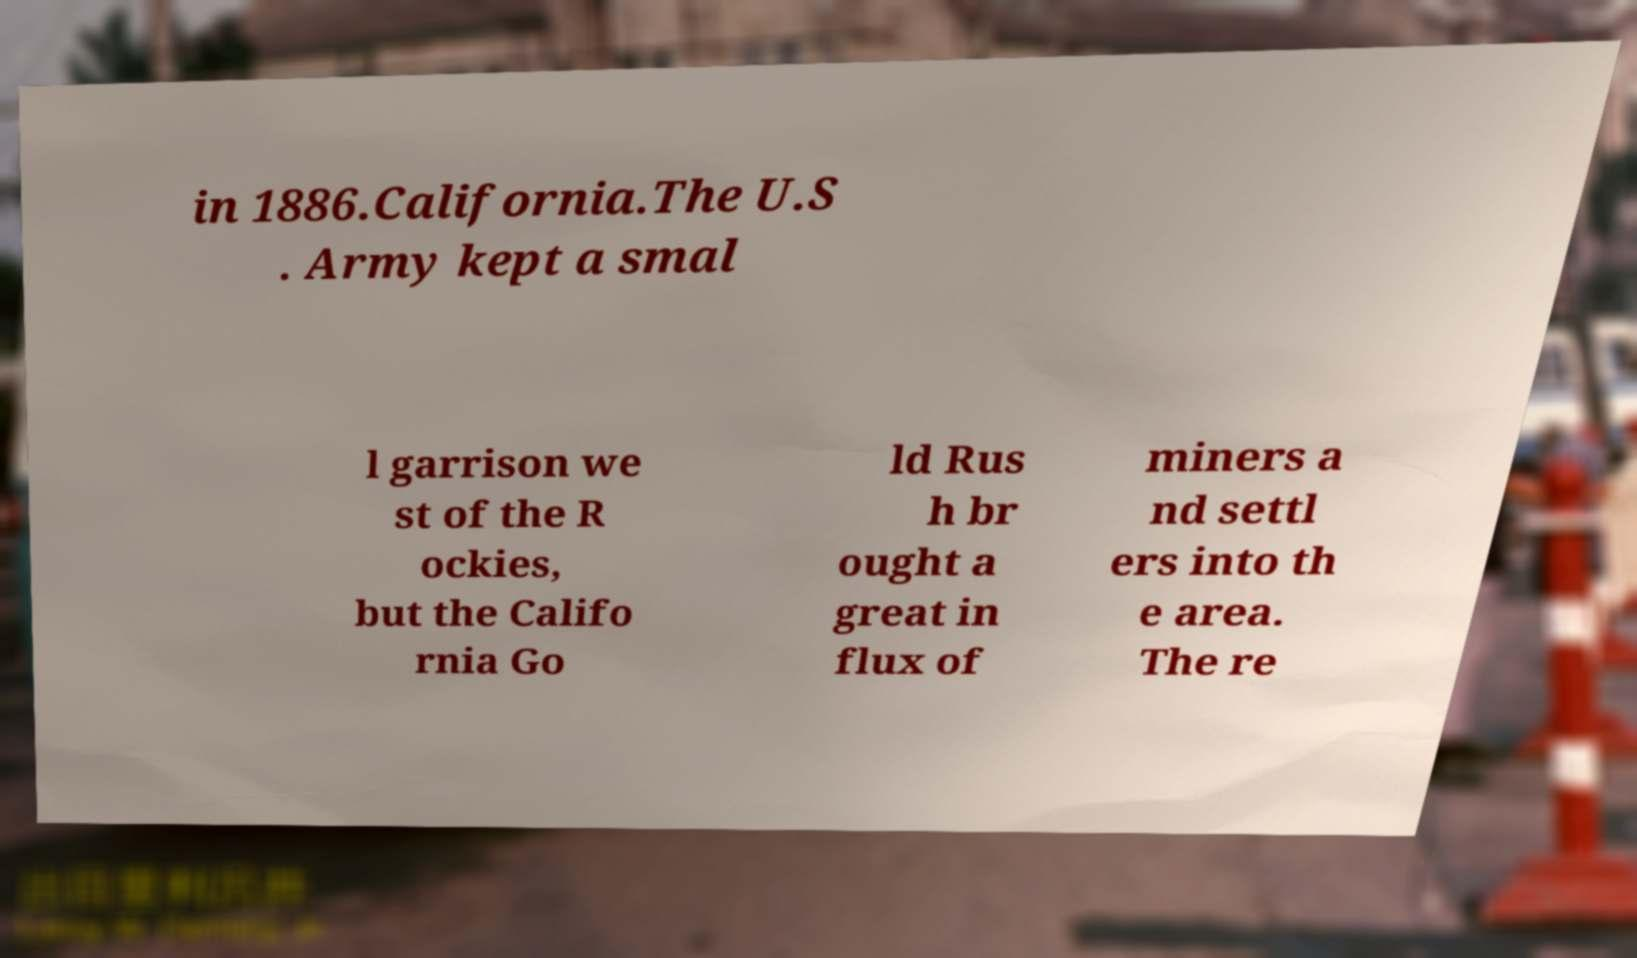I need the written content from this picture converted into text. Can you do that? in 1886.California.The U.S . Army kept a smal l garrison we st of the R ockies, but the Califo rnia Go ld Rus h br ought a great in flux of miners a nd settl ers into th e area. The re 